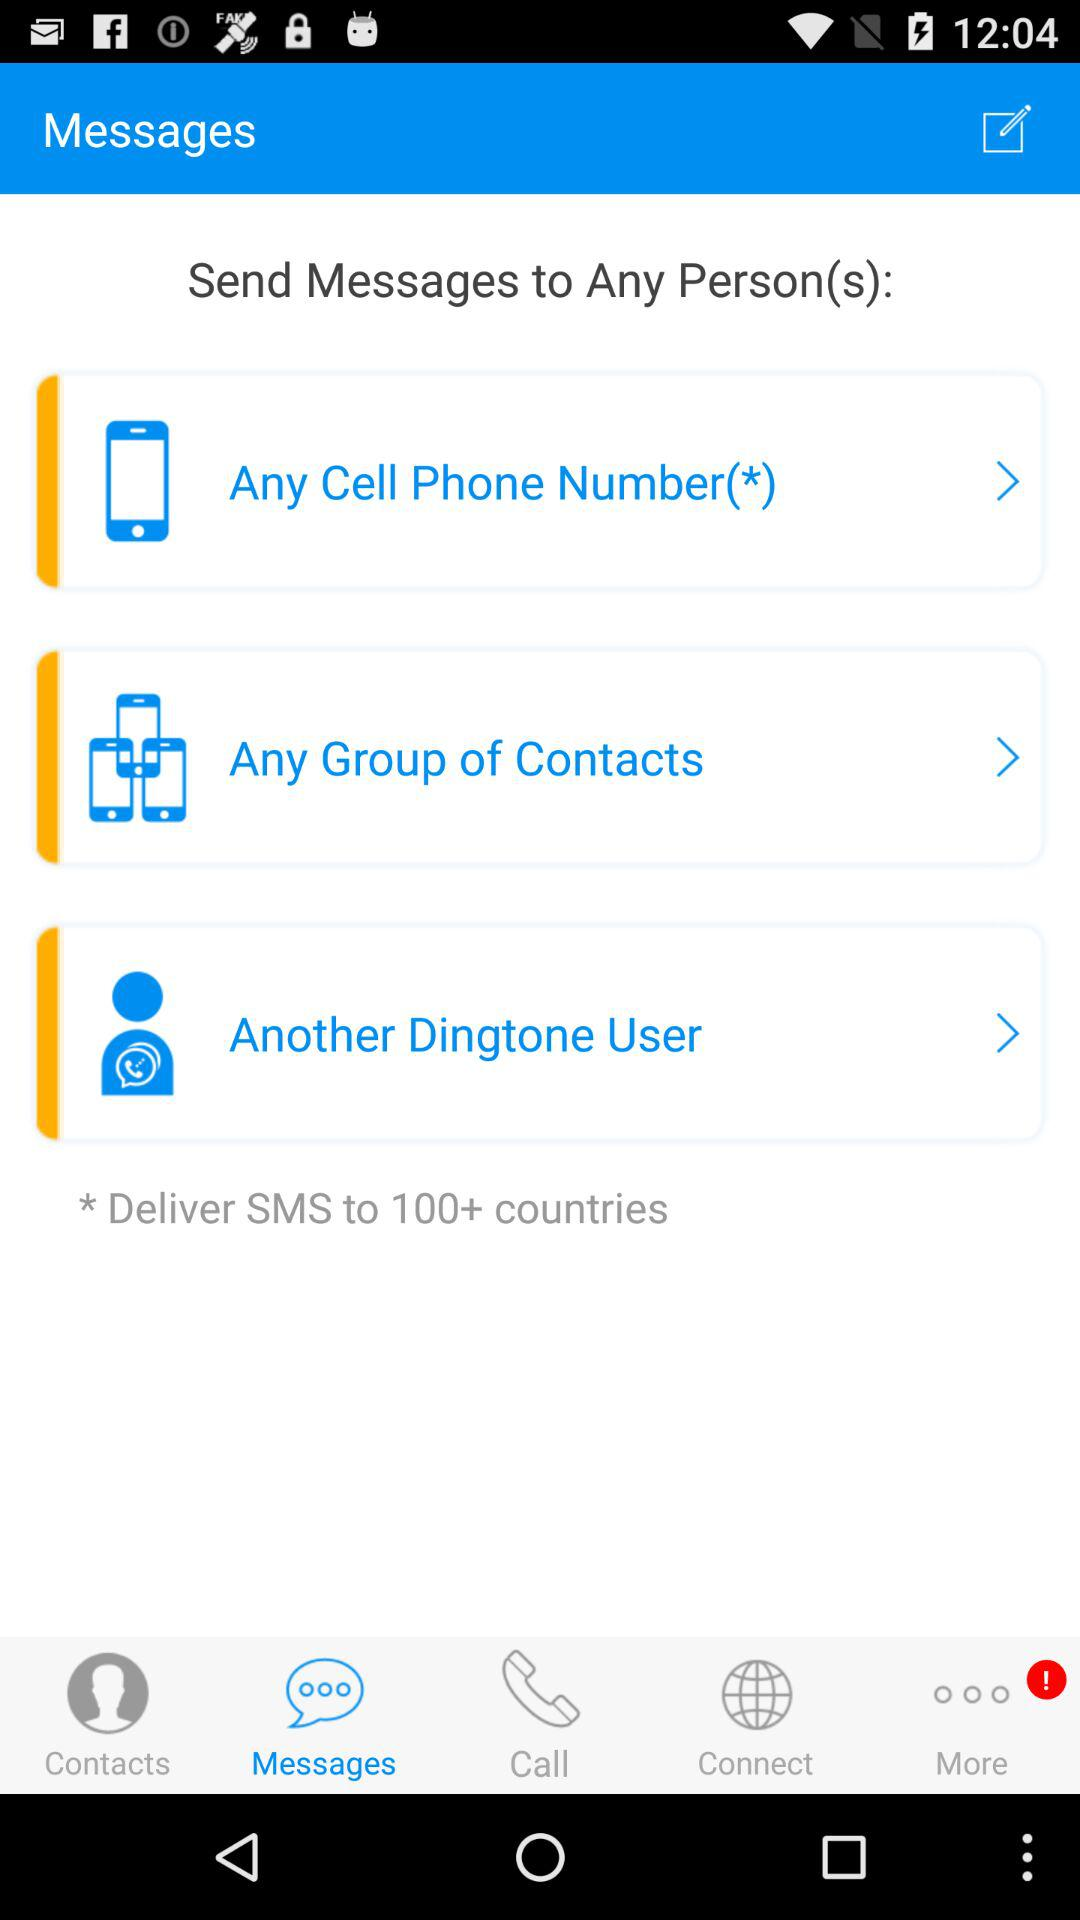How many notifications are in more options?
When the provided information is insufficient, respond with <no answer>. <no answer> 